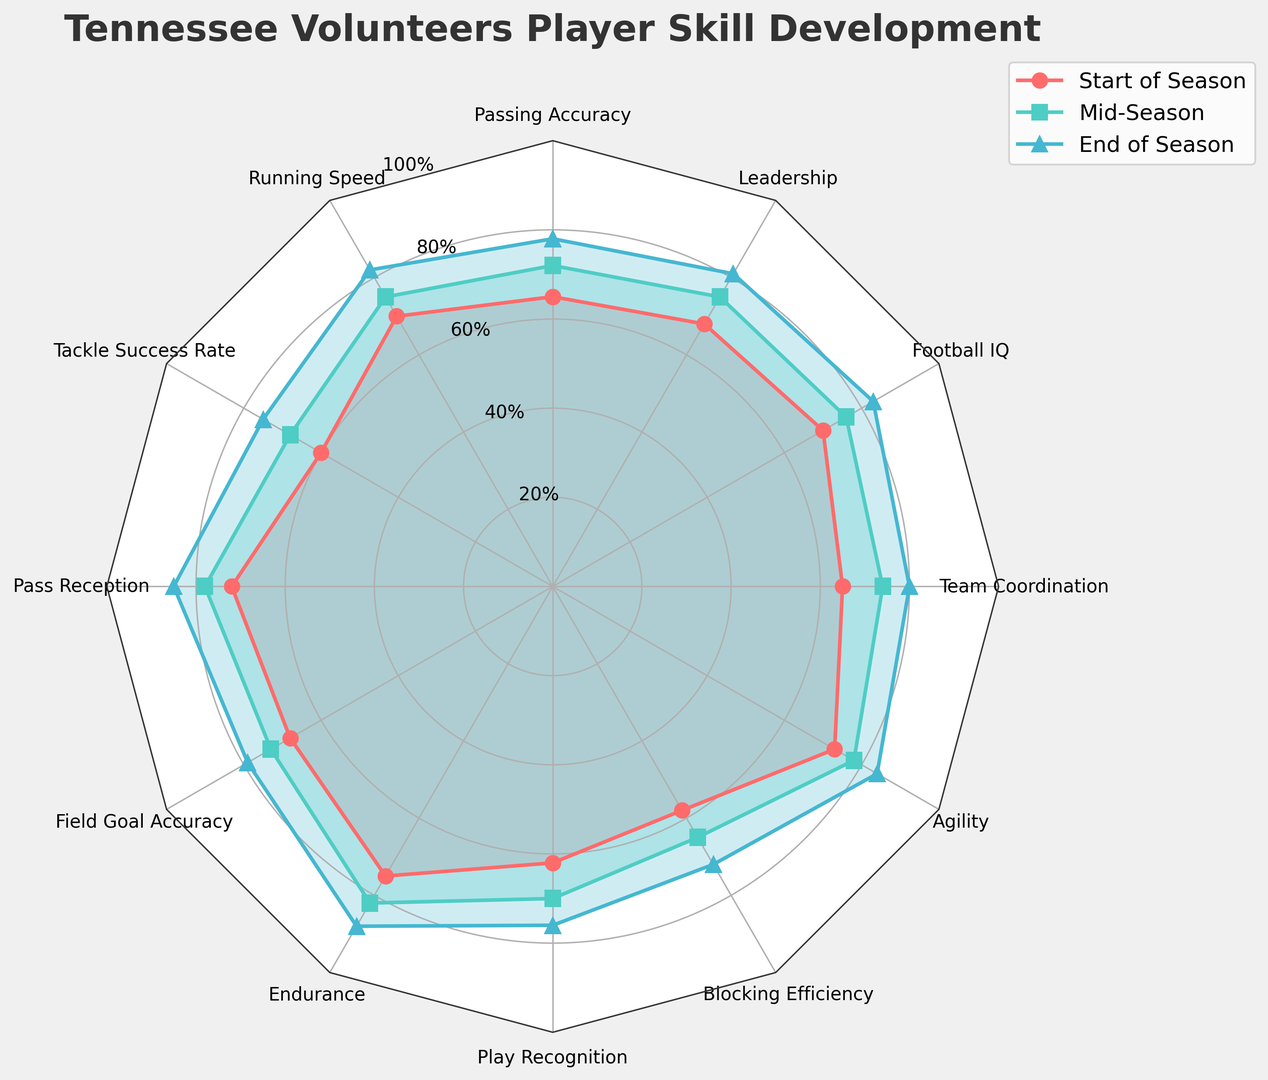Which skill saw the largest improvement from the start of the season to the end of the season? Look at the values of each skill at the start and end of the season and calculate the difference. Endurance improved the most, going from 75 to 88, an increase of 13 points.
Answer: Endurance Which skill had the smallest improvement from mid-season to end of season? Examine the mid-season and end-of-season values for each skill and find the difference. Blocking Efficiency had the smallest improvement, increasing from 65 to 72, an improvement of 7 points.
Answer: Blocking Efficiency What is the average improvement of all skills from the start of the season to the end of the season? Calculate the difference for each skill between the start and end of the season. Then, sum these differences and divide by the number of skills. (13+12+15+13+11+7+14+10+11+15+13+9)/12 = 12
Answer: 12 Which skills had a higher end-of-season score than their mid-season score by the same amount? Compare the mid-season and end-of-season scores for each skill and find those with the same differences. Both Running Speed and Agility increased by 7 points from mid-season to end-of-season.
Answer: Running Speed and Agility What is the difference between the highest end-of-season score and the lowest end-of-season score? Identify the highest and lowest end-of-season scores. The highest is Endurance at 88, and the lowest is Blocking Efficiency at 72. The difference is 88-72 = 16.
Answer: 16 Which skill had the highest mid-season score? Review the scores for each skill at mid-season and find the highest one. Pass Reception had the highest mid-season score at 78.
Answer: Pass Reception By how much did Passing Accuracy improve from the start to mid-season, and from mid-season to end of season? Calculate the difference between the start and mid-season scores and the mid-season and end-of-season scores for Passing Accuracy. From start to mid-season: 72-65 = 7, and from mid-season to end-season: 78-72 = 6.
Answer: 7 and 6 What is the sum of the end-of-season scores for Leadership, Football IQ, and Team Coordination? Add the end-of-season scores of these skills: Leadership (81), Football IQ (83), and Team Coordination (80). The sum is 81+83+80 = 244
Answer: 244 Which skill showed the least change from the start of the season to mid-season? Look at the differences between start and mid-season scores for each skill. The smallest change occurred in Blocking Efficiency, going from 58 to 65, a change of 7.
Answer: Blocking Efficiency 